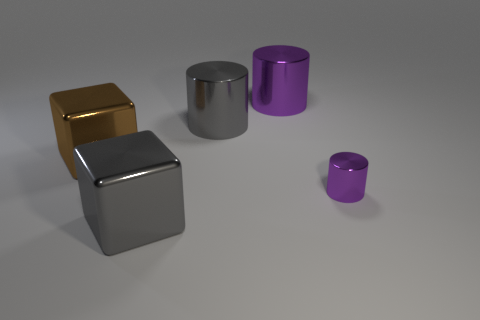Does the big gray cube have the same material as the purple cylinder that is in front of the brown metal thing?
Give a very brief answer. Yes. There is a thing on the right side of the big cylinder that is right of the big metallic cylinder that is on the left side of the big purple thing; what is its shape?
Offer a very short reply. Cylinder. How many objects are big brown matte blocks or shiny objects that are behind the gray block?
Keep it short and to the point. 4. Are there fewer big metal cylinders than big things?
Provide a succinct answer. Yes. The large metal cylinder that is on the left side of the purple thing that is behind the purple object in front of the brown metal thing is what color?
Your answer should be compact. Gray. Is the material of the brown block the same as the gray cube?
Provide a succinct answer. Yes. What number of big brown blocks are on the right side of the large brown block?
Offer a very short reply. 0. There is another purple metal object that is the same shape as the large purple metallic thing; what is its size?
Make the answer very short. Small. How many gray things are either metallic things or cubes?
Offer a terse response. 2. There is a block in front of the small purple thing; how many big brown metal blocks are on the left side of it?
Ensure brevity in your answer.  1. 